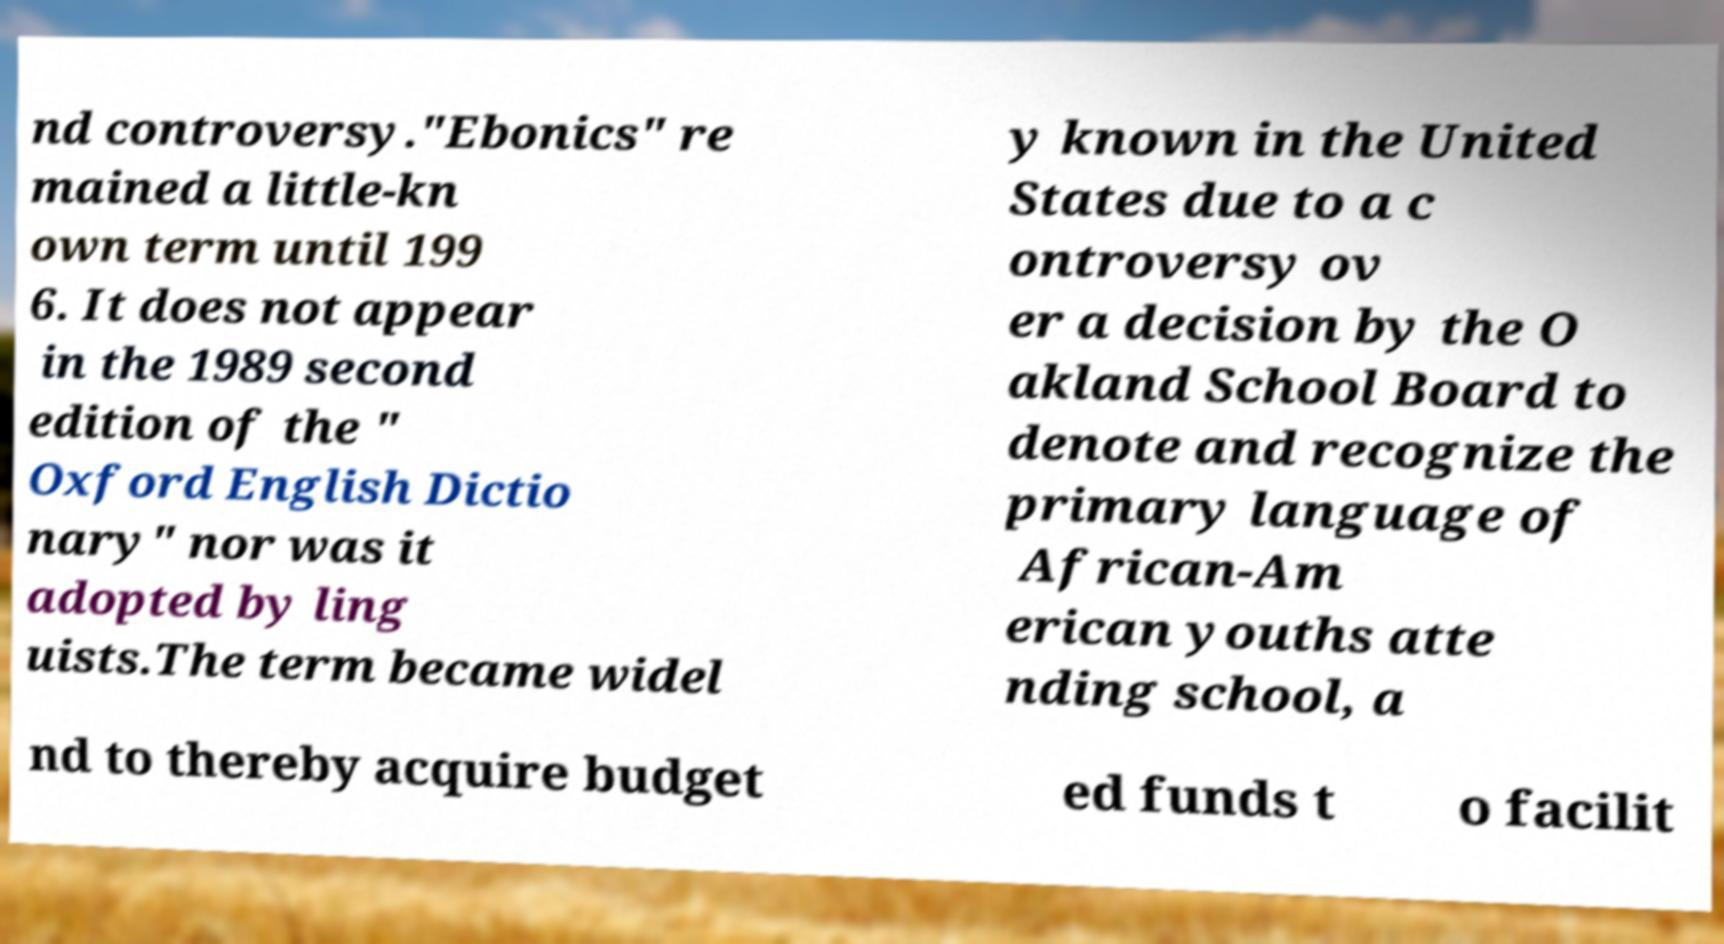Please read and relay the text visible in this image. What does it say? nd controversy."Ebonics" re mained a little-kn own term until 199 6. It does not appear in the 1989 second edition of the " Oxford English Dictio nary" nor was it adopted by ling uists.The term became widel y known in the United States due to a c ontroversy ov er a decision by the O akland School Board to denote and recognize the primary language of African-Am erican youths atte nding school, a nd to thereby acquire budget ed funds t o facilit 